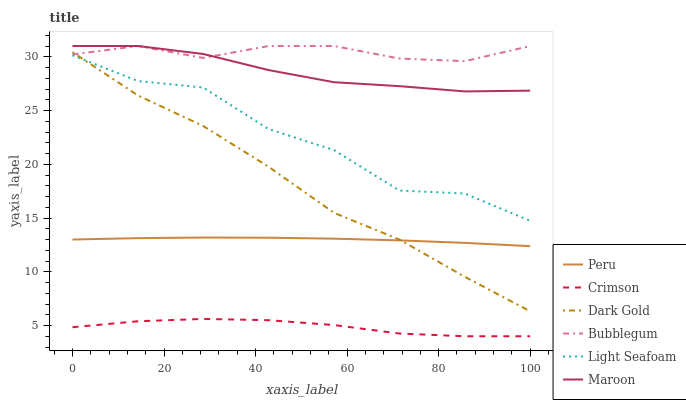Does Crimson have the minimum area under the curve?
Answer yes or no. Yes. Does Bubblegum have the maximum area under the curve?
Answer yes or no. Yes. Does Maroon have the minimum area under the curve?
Answer yes or no. No. Does Maroon have the maximum area under the curve?
Answer yes or no. No. Is Peru the smoothest?
Answer yes or no. Yes. Is Light Seafoam the roughest?
Answer yes or no. Yes. Is Maroon the smoothest?
Answer yes or no. No. Is Maroon the roughest?
Answer yes or no. No. Does Crimson have the lowest value?
Answer yes or no. Yes. Does Maroon have the lowest value?
Answer yes or no. No. Does Bubblegum have the highest value?
Answer yes or no. Yes. Does Peru have the highest value?
Answer yes or no. No. Is Crimson less than Maroon?
Answer yes or no. Yes. Is Light Seafoam greater than Peru?
Answer yes or no. Yes. Does Bubblegum intersect Maroon?
Answer yes or no. Yes. Is Bubblegum less than Maroon?
Answer yes or no. No. Is Bubblegum greater than Maroon?
Answer yes or no. No. Does Crimson intersect Maroon?
Answer yes or no. No. 